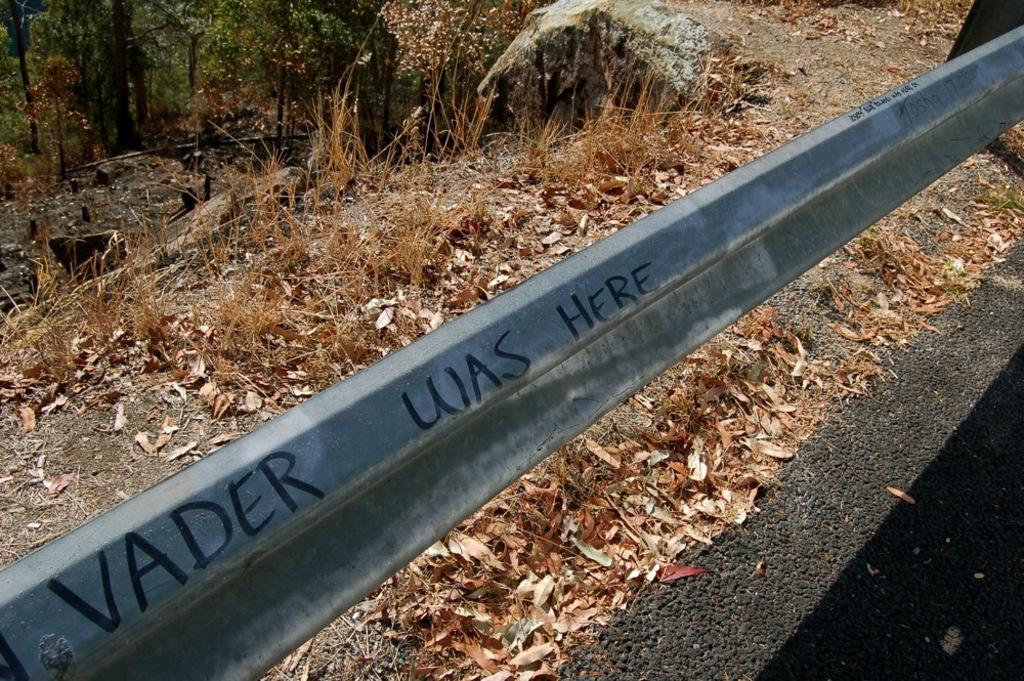What is located in the middle of the image? There is a fencing in the middle of the image. What can be seen behind the fencing? Leaves, grass, and trees are visible behind the fencing. Can you describe the natural elements in the image? The natural elements include leaves, grass, and trees. What type of stew is being prepared by the creator in the image? There is no stew or creator present in the image; it features a fencing with natural elements behind it. Can you tell me the color of the cat in the image? There is no cat present in the image. 